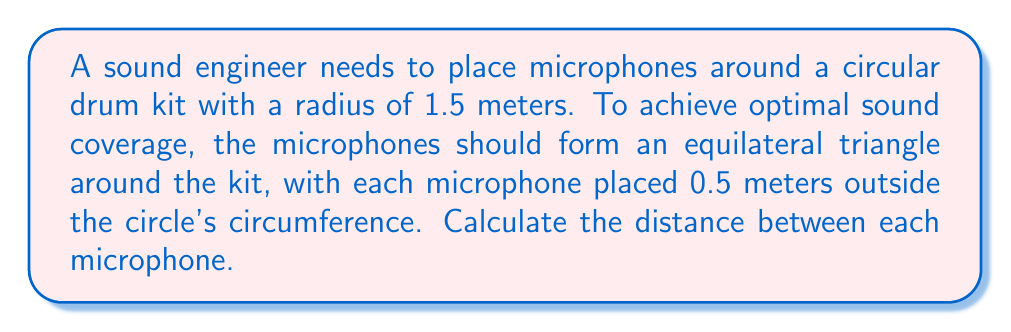Could you help me with this problem? Let's approach this step-by-step:

1) First, we need to understand the geometry. We have a circle (the drum kit) with three points (the microphones) forming an equilateral triangle around it.

2) The radius of the circle (drum kit) is 1.5 meters, and the microphones are placed 0.5 meters outside the circumference. So, the distance from the center of the circle to each microphone is:

   $$r = 1.5 + 0.5 = 2 \text{ meters}$$

3) Now, we have an equilateral triangle with its vertices 2 meters from the center of the circle. We need to find the side length of this triangle.

4) In an equilateral triangle, the distance from the center to any vertex is related to the side length by the formula:

   $$r = \frac{a}{\sqrt{3}}$$

   Where $r$ is the radius (distance from center to vertex) and $a$ is the side length.

5) We can rearrange this to solve for $a$:

   $$a = r\sqrt{3}$$

6) Substituting our value for $r$:

   $$a = 2\sqrt{3} \text{ meters}$$

7) Therefore, the distance between each microphone is $2\sqrt{3}$ meters.

[asy]
unitsize(30);
draw(circle((0,0),1.5), rgb(0,0,1));
pair A = (2,0);
pair B = 2*dir(120);
pair C = 2*dir(240);
draw(A--B--C--cycle, rgb(1,0,0));
dot(A); dot(B); dot(C);
label("Mic 1", A, E);
label("Mic 2", B, NW);
label("Mic 3", C, SW);
label("1.5m", (0,0)--(1.5,0), S);
label("0.5m", (1.5,0)--(2,0), S);
[/asy]
Answer: $2\sqrt{3}$ meters 